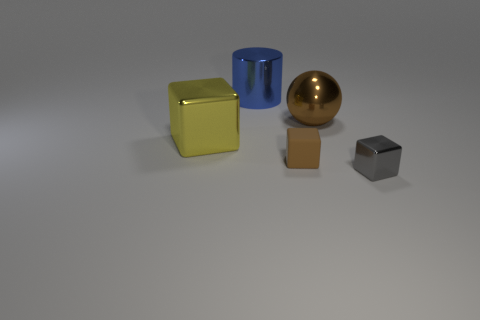Is there any other thing that has the same material as the small brown cube?
Provide a succinct answer. No. Are there more things to the left of the blue object than yellow metallic cubes that are to the left of the yellow shiny cube?
Ensure brevity in your answer.  Yes. There is a large yellow object that is the same material as the blue object; what shape is it?
Your response must be concise. Cube. What number of other things are the same shape as the yellow thing?
Give a very brief answer. 2. The tiny gray metallic thing right of the large yellow shiny object has what shape?
Your answer should be very brief. Cube. The small shiny object is what color?
Your answer should be compact. Gray. What number of other things are the same size as the rubber object?
Your answer should be compact. 1. What is the tiny cube that is behind the shiny block that is in front of the yellow cube made of?
Offer a very short reply. Rubber. There is a brown sphere; is its size the same as the block in front of the small rubber thing?
Keep it short and to the point. No. Is there a small metallic thing of the same color as the big metal block?
Offer a very short reply. No. 